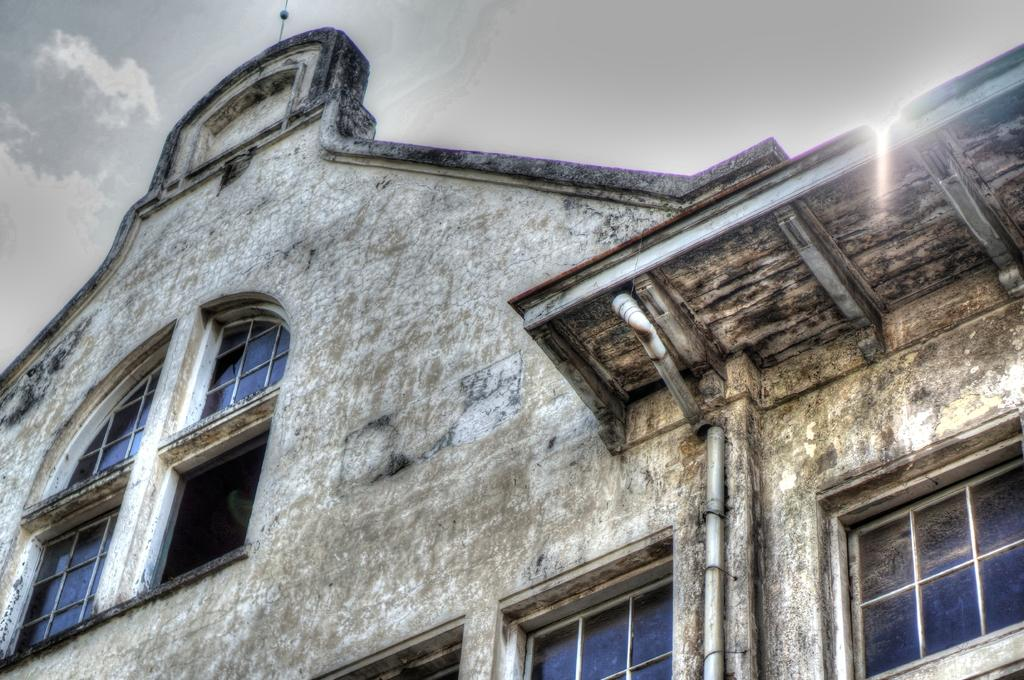What type of structure can be seen in the image? There is a wall in the image. Are there any openings in the wall? Yes, there are windows in the image. What can be seen in the background of the image? The sky is visible in the background of the image. What is the condition of the sky in the image? Clouds are present in the sky. What type of authority figure can be seen in the image? There is no authority figure present in the image. How many spiders are visible on the wall in the image? There are no spiders visible on the wall in the image. 